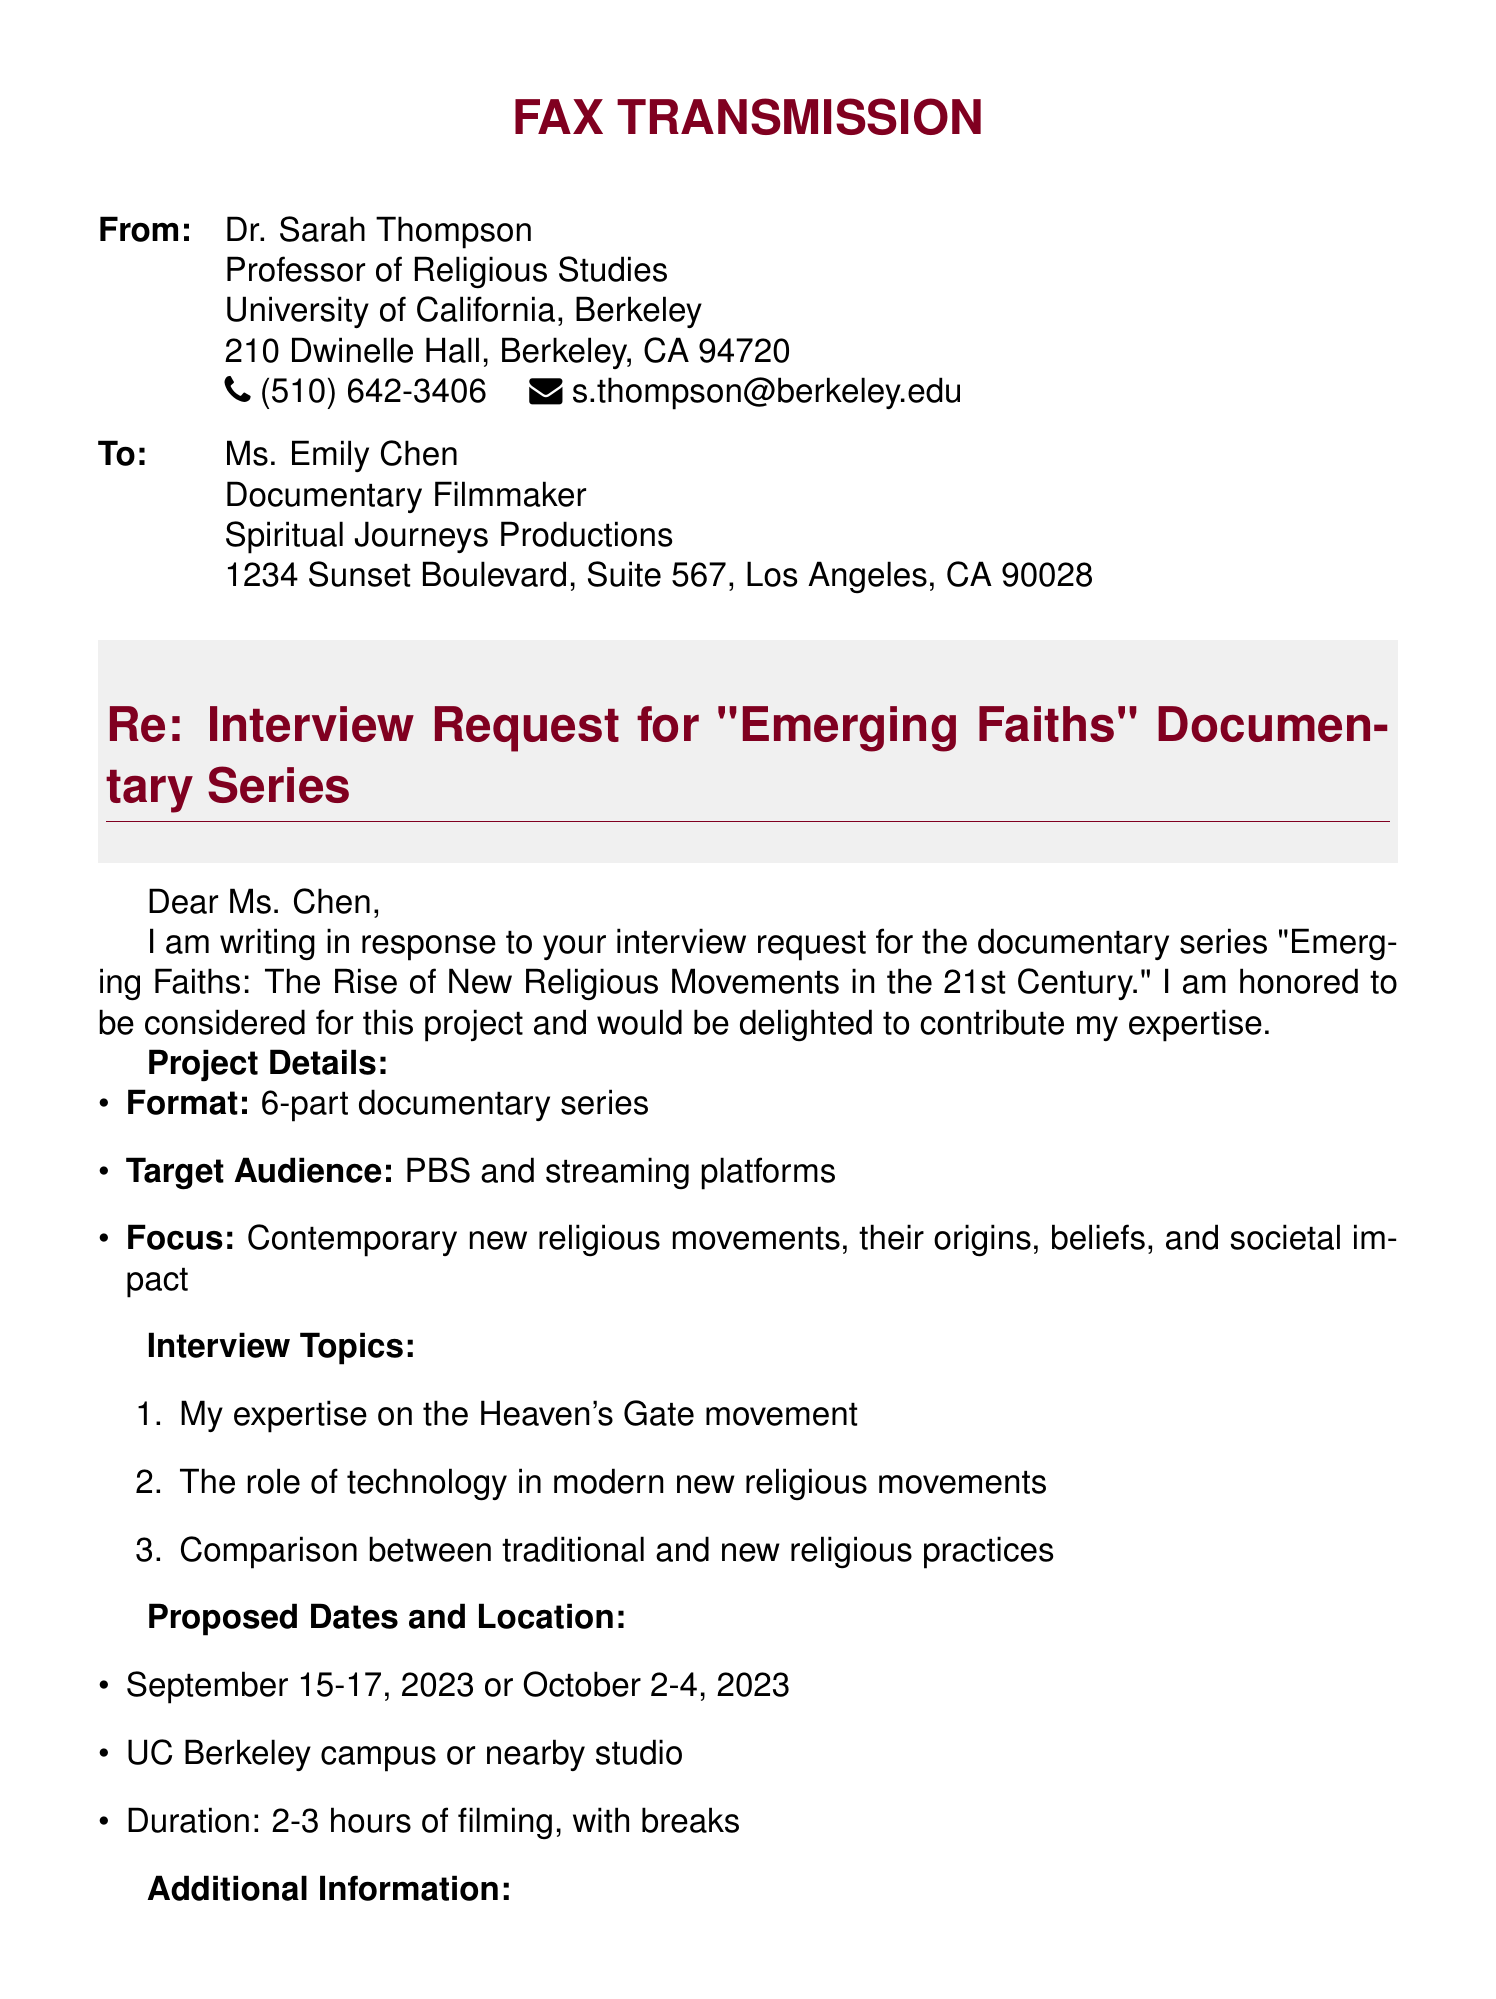what is the name of the documentary series? The document mentions the title of the documentary series as "Emerging Faiths: The Rise of New Religious Movements in the 21st Century."
Answer: "Emerging Faiths: The Rise of New Religious Movements in the 21st Century" who is the filmmaker of the documentary? The document addresses the filmmaker as Ms. Emily Chen from Spiritual Journeys Productions.
Answer: Ms. Emily Chen how many parts does the documentary series have? The document states that the series consists of a 6-part format.
Answer: 6-part what are the proposed filming dates? The document lists two options for filming: September 15-17, 2023 or October 2-4, 2023.
Answer: September 15-17, 2023 or October 2-4, 2023 what is the honorarium offered for participation? The document specifies an honorarium of $500 for participation in the interview.
Answer: $500 what are the topics of the interview? The document includes specific topics such as Heaven's Gate movement and the role of technology.
Answer: Heaven's Gate movement, technology, comparison of practices where will the filming take place? The document indicates potential filming locations as the UC Berkeley campus or a nearby studio.
Answer: UC Berkeley campus or nearby studio what is the duration of the filming? The document notes that the filming duration will be 2-3 hours, including breaks.
Answer: 2-3 hours what right does Dr. Thompson have regarding the final cut of her segment? The document mentions that Dr. Thompson has the right to review and approve the final cut of her segments.
Answer: Right to review and approve final cut 